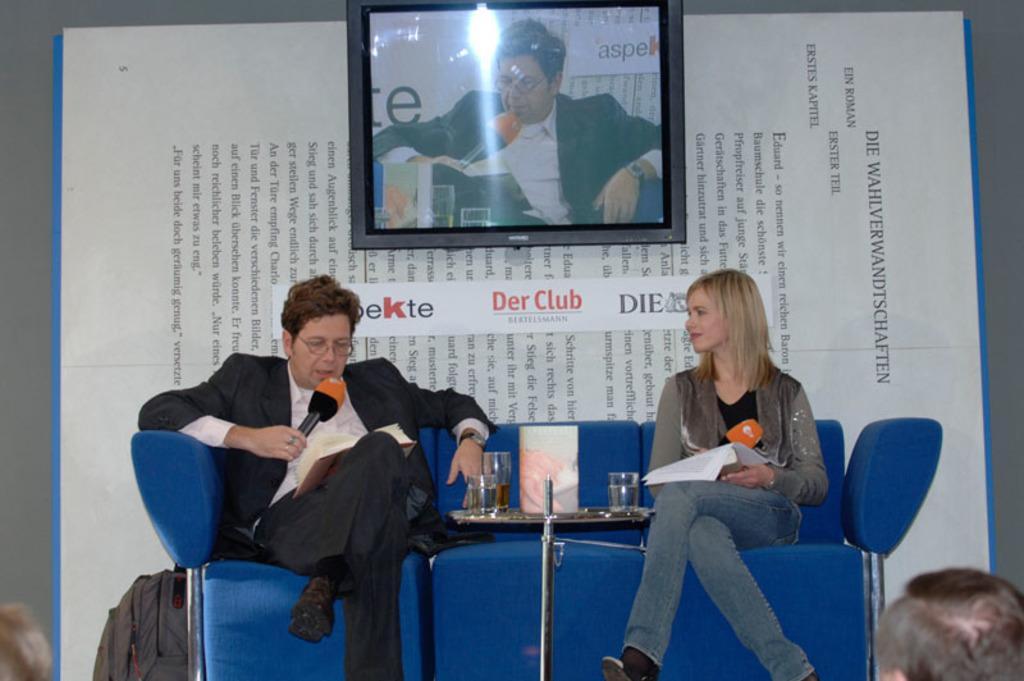Could you give a brief overview of what you see in this image? In the image in the center, we can see two persons are sitting and they are holding microphones and books. Between them, there is a table. On the table, we can see glasses and a few other objects. In the background there is a screen, banner and a few other objects. 